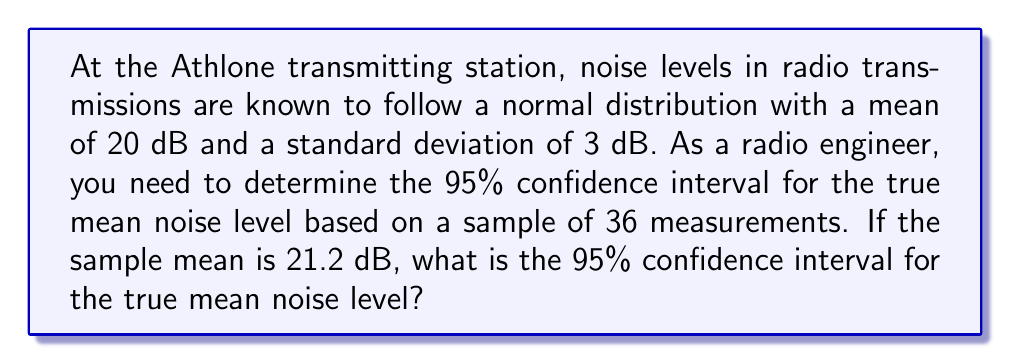Teach me how to tackle this problem. Let's approach this step-by-step:

1) We are given:
   - Population standard deviation, $\sigma = 3$ dB
   - Sample size, $n = 36$
   - Sample mean, $\bar{x} = 21.2$ dB
   - Confidence level = 95%

2) For a 95% confidence interval, we use a z-score of 1.96 (from the standard normal distribution table).

3) The formula for the confidence interval is:

   $$\bar{x} \pm z \cdot \frac{\sigma}{\sqrt{n}}$$

4) Let's calculate the margin of error:

   $$\text{Margin of Error} = z \cdot \frac{\sigma}{\sqrt{n}} = 1.96 \cdot \frac{3}{\sqrt{36}} = 1.96 \cdot 0.5 = 0.98$$

5) Now, we can calculate the confidence interval:

   Lower bound: $21.2 - 0.98 = 20.22$ dB
   Upper bound: $21.2 + 0.98 = 22.18$ dB

6) Therefore, we are 95% confident that the true mean noise level falls between 20.22 dB and 22.18 dB.
Answer: (20.22 dB, 22.18 dB) 